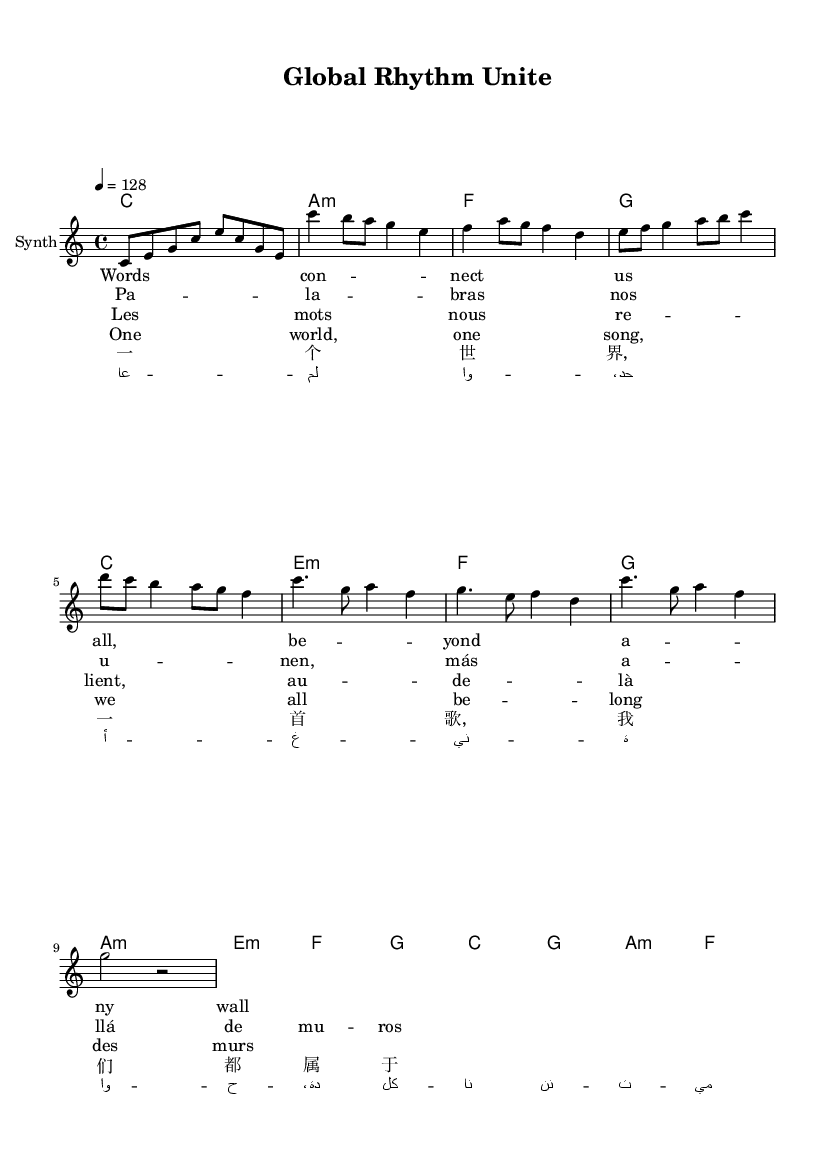What is the key signature of this music? The key signature is indicated at the beginning of the notation. In this case, it shows C major, which is represented by the absence of sharps or flats.
Answer: C major What is the time signature of this music? The time signature appears at the beginning, and it is indicated as 4/4, which means there are four beats in each measure and a quarter note receives one beat.
Answer: 4/4 What is the tempo of this piece? The tempo is specified as "4 = 128" in the score, indicating that there are 128 beats per minute.
Answer: 128 How many languages are used in the lyrics? By counting the different sets of lyrics in the score, there are lyrics in English, Spanish, French, Chinese, and Arabic, totaling five different languages.
Answer: Five What is the pattern of the chorus? The chorus has a repeating pattern which can be identified by the lyrics provided. Both sections follow the same melodic structure, emphasizing the global theme of unity.
Answer: Repeating Which instruments are indicated in the score? The score indicates a "Synth" as the instrument for the melody part, and it has chord names provided as harmonies to accompany the melody.
Answer: Synth 